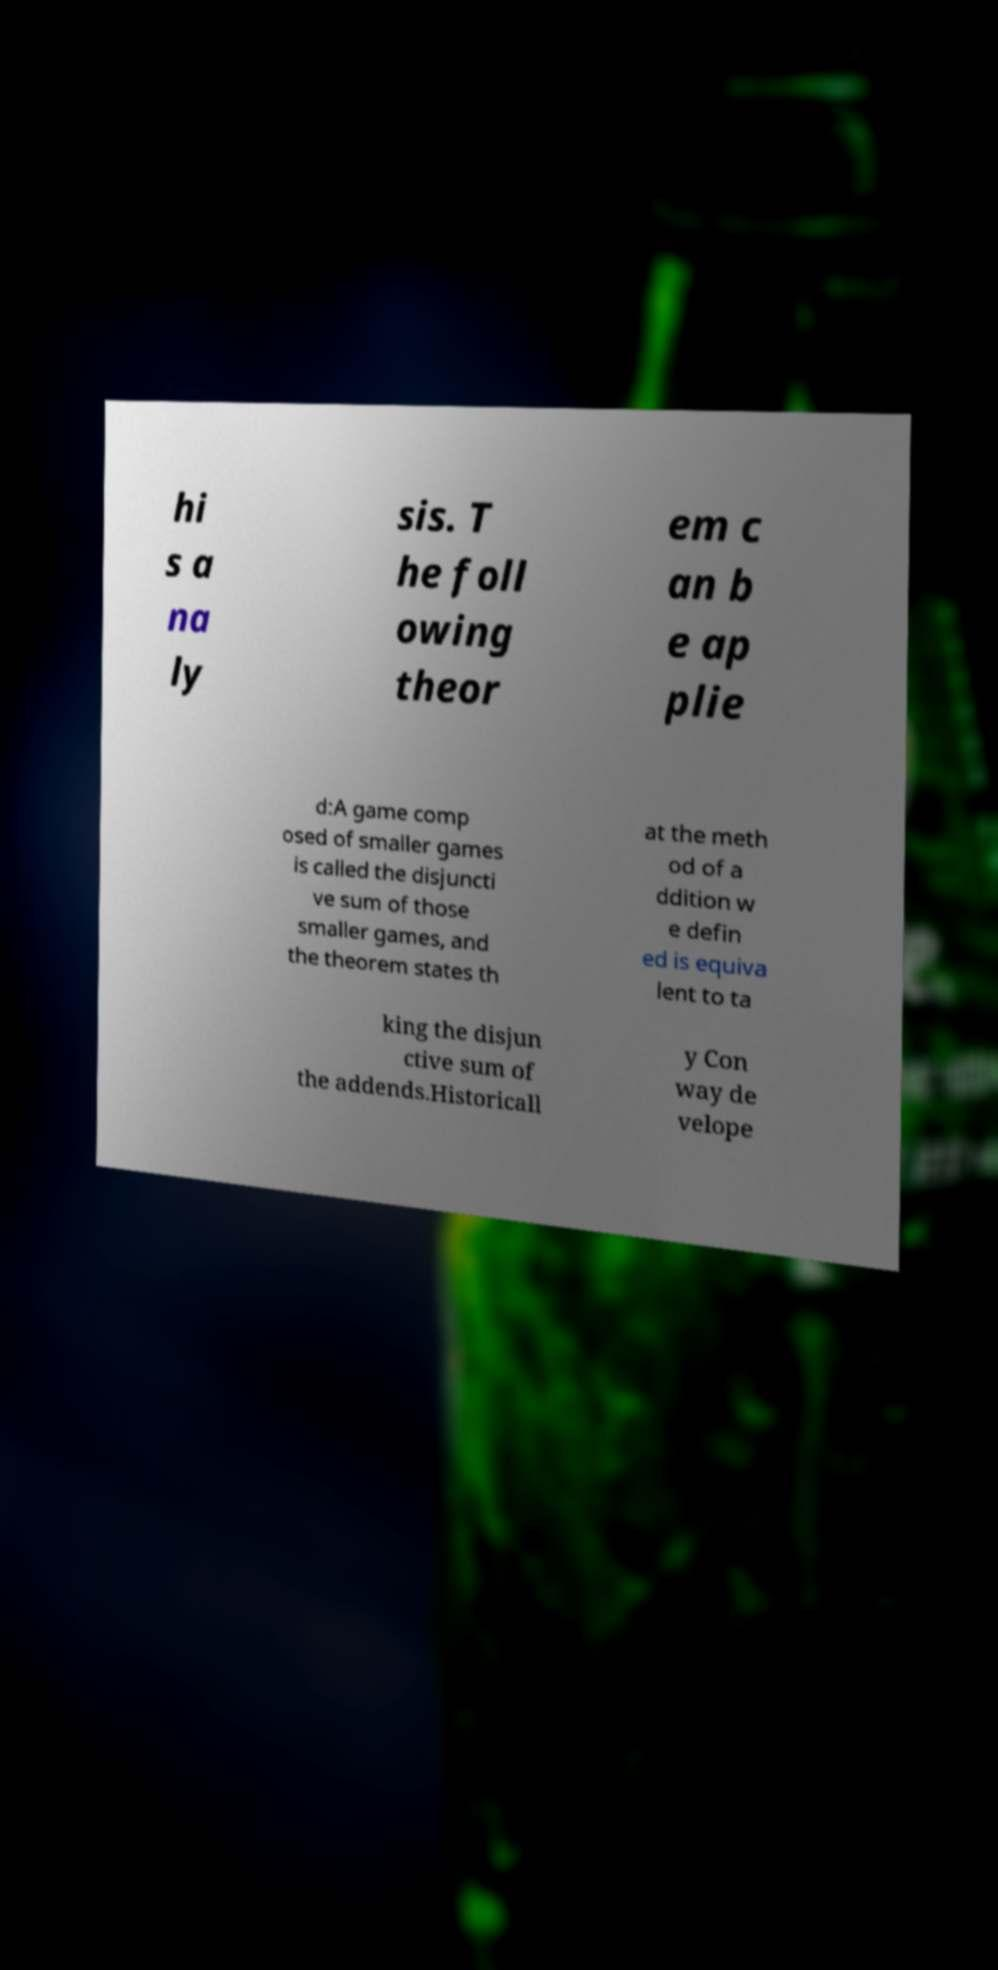For documentation purposes, I need the text within this image transcribed. Could you provide that? hi s a na ly sis. T he foll owing theor em c an b e ap plie d:A game comp osed of smaller games is called the disjuncti ve sum of those smaller games, and the theorem states th at the meth od of a ddition w e defin ed is equiva lent to ta king the disjun ctive sum of the addends.Historicall y Con way de velope 